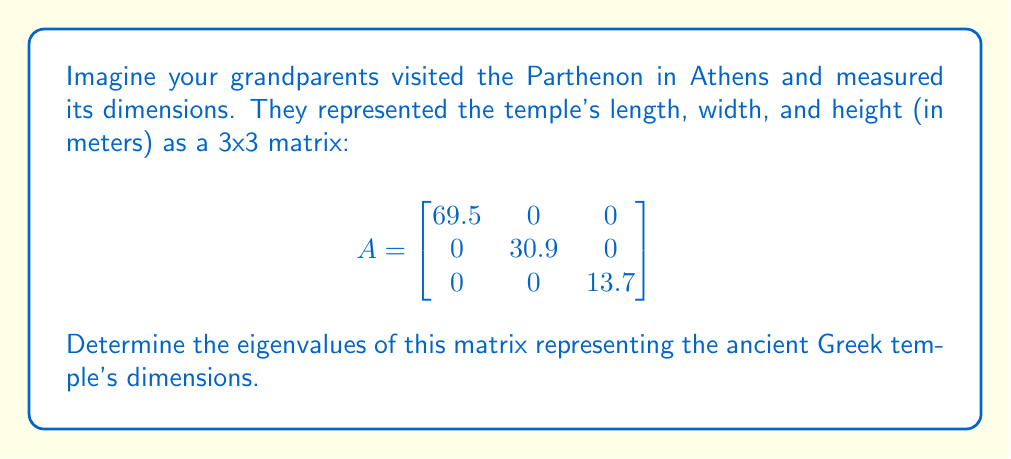Show me your answer to this math problem. To find the eigenvalues of matrix A, we need to solve the characteristic equation:

1) The characteristic equation is given by $\det(A - \lambda I) = 0$, where $\lambda$ represents the eigenvalues and $I$ is the 3x3 identity matrix.

2) Expanding the determinant:

   $$\det\begin{bmatrix}
   69.5 - \lambda & 0 & 0 \\
   0 & 30.9 - \lambda & 0 \\
   0 & 0 & 13.7 - \lambda
   \end{bmatrix} = 0$$

3) For a diagonal matrix, the determinant is the product of its diagonal elements:

   $(69.5 - \lambda)(30.9 - \lambda)(13.7 - \lambda) = 0$

4) The solutions to this equation are the eigenvalues. Each factor set to zero gives an eigenvalue:

   $69.5 - \lambda = 0$, or $\lambda = 69.5$
   $30.9 - \lambda = 0$, or $\lambda = 30.9$
   $13.7 - \lambda = 0$, or $\lambda = 13.7$

Therefore, the eigenvalues are 69.5, 30.9, and 13.7.
Answer: $\lambda_1 = 69.5$, $\lambda_2 = 30.9$, $\lambda_3 = 13.7$ 